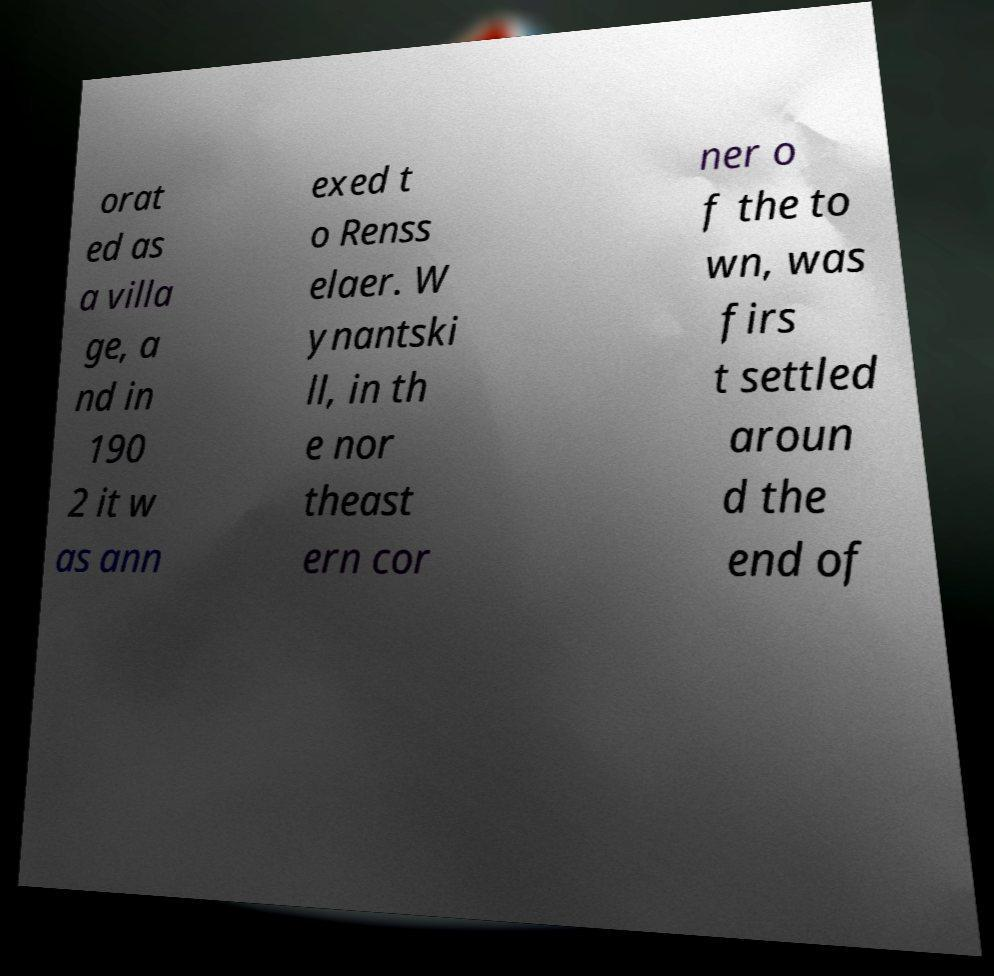For documentation purposes, I need the text within this image transcribed. Could you provide that? orat ed as a villa ge, a nd in 190 2 it w as ann exed t o Renss elaer. W ynantski ll, in th e nor theast ern cor ner o f the to wn, was firs t settled aroun d the end of 